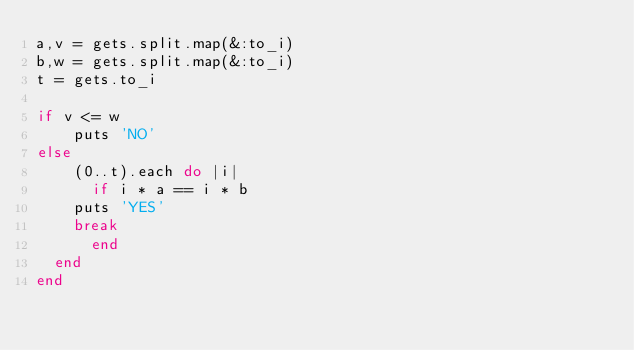<code> <loc_0><loc_0><loc_500><loc_500><_Ruby_>a,v = gets.split.map(&:to_i)
b,w = gets.split.map(&:to_i)
t = gets.to_i

if v <= w
    puts 'NO'
else 
    (0..t).each do |i|
      if i * a == i * b
    puts 'YES'
    break
      end
  end
end</code> 